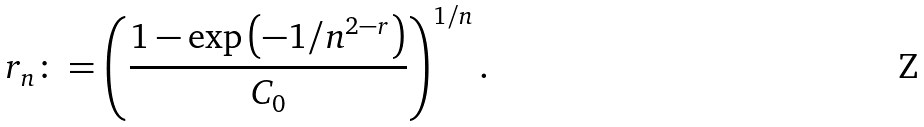<formula> <loc_0><loc_0><loc_500><loc_500>r _ { n } \colon = \left ( \frac { 1 - \exp \left ( - 1 / n ^ { 2 - r } \right ) } { C _ { 0 } } \right ) ^ { { 1 } / { n } } .</formula> 